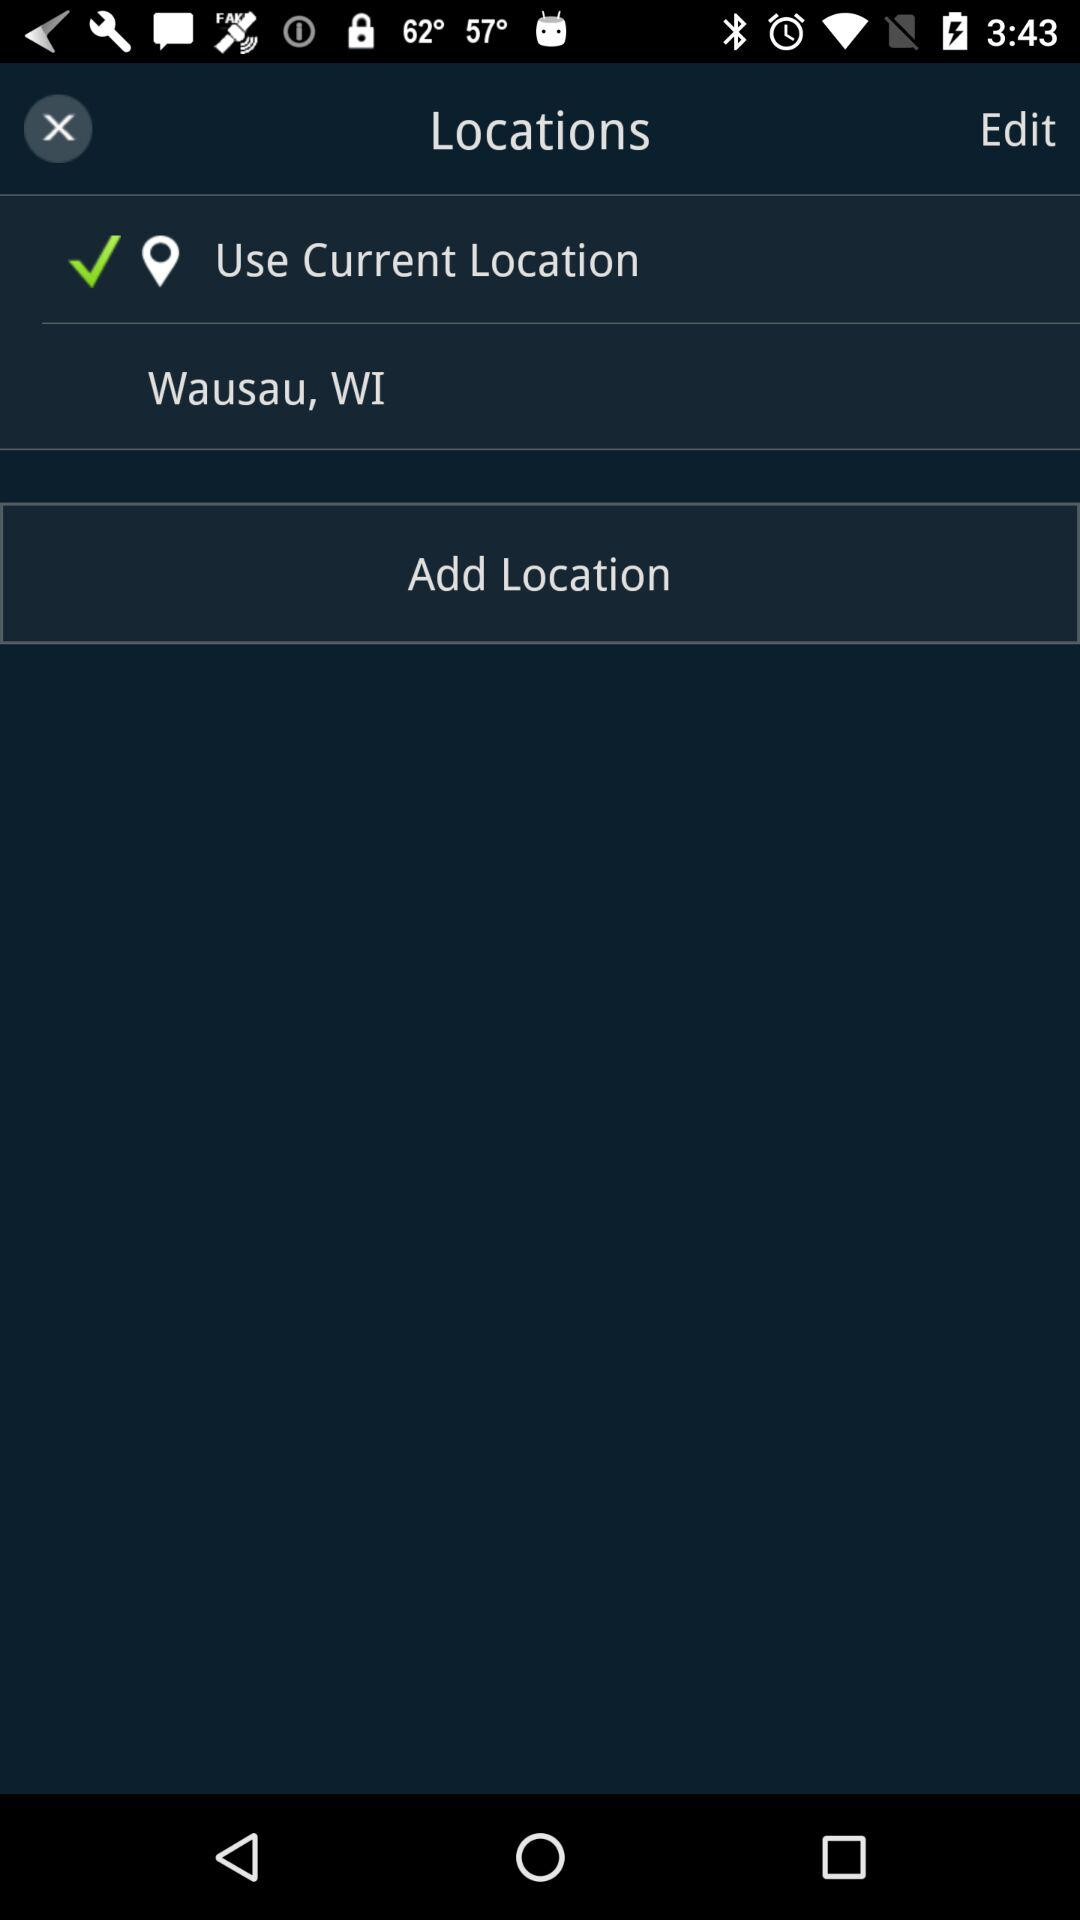How many locations are not marked as the current location?
Answer the question using a single word or phrase. 1 